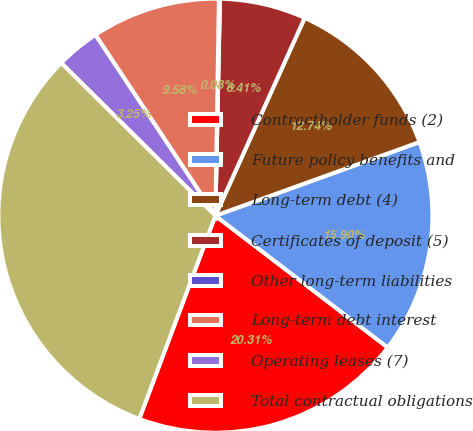Convert chart. <chart><loc_0><loc_0><loc_500><loc_500><pie_chart><fcel>Contractholder funds (2)<fcel>Future policy benefits and<fcel>Long-term debt (4)<fcel>Certificates of deposit (5)<fcel>Other long-term liabilities<fcel>Long-term debt interest<fcel>Operating leases (7)<fcel>Total contractual obligations<nl><fcel>20.31%<fcel>15.9%<fcel>12.74%<fcel>6.41%<fcel>0.08%<fcel>9.58%<fcel>3.25%<fcel>31.72%<nl></chart> 